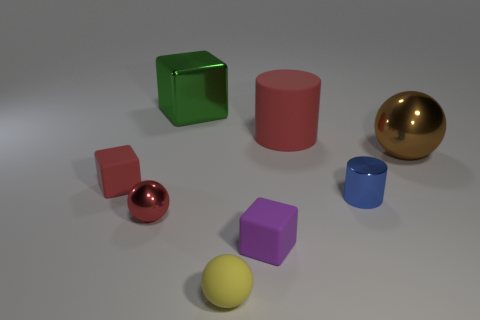Can you describe the lighting in this scene? The lighting in the image appears to be soft and diffused, coming from an overhead source. The shadows cast by the objects are soft-edged and relatively short, suggesting the light source is not extremely close but provide ample illumination without causing very hard shadows. This kind of lighting is commonly used in studio setups to create a clean and clear presentation of objects. 